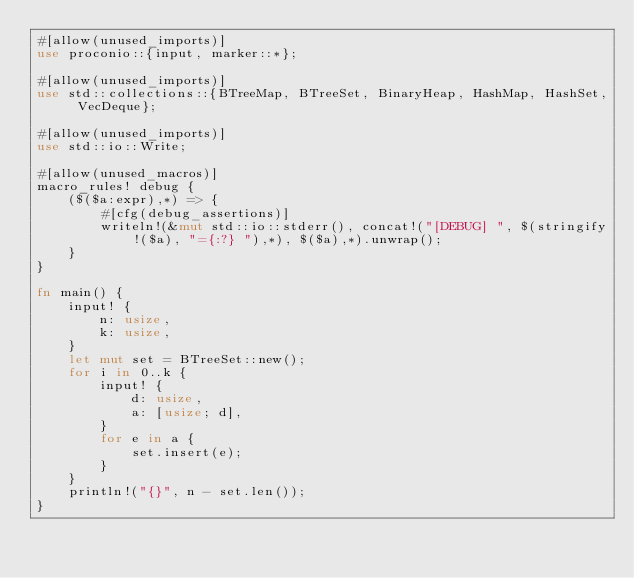<code> <loc_0><loc_0><loc_500><loc_500><_Rust_>#[allow(unused_imports)]
use proconio::{input, marker::*};

#[allow(unused_imports)]
use std::collections::{BTreeMap, BTreeSet, BinaryHeap, HashMap, HashSet, VecDeque};

#[allow(unused_imports)]
use std::io::Write;

#[allow(unused_macros)]
macro_rules! debug {
    ($($a:expr),*) => {
        #[cfg(debug_assertions)]
        writeln!(&mut std::io::stderr(), concat!("[DEBUG] ", $(stringify!($a), "={:?} "),*), $($a),*).unwrap();
    }
}

fn main() {
    input! {
        n: usize,
        k: usize,
    }
    let mut set = BTreeSet::new();
    for i in 0..k {
        input! {
            d: usize,
            a: [usize; d],
        }
        for e in a {
            set.insert(e);
        }
    }
    println!("{}", n - set.len());
}
</code> 